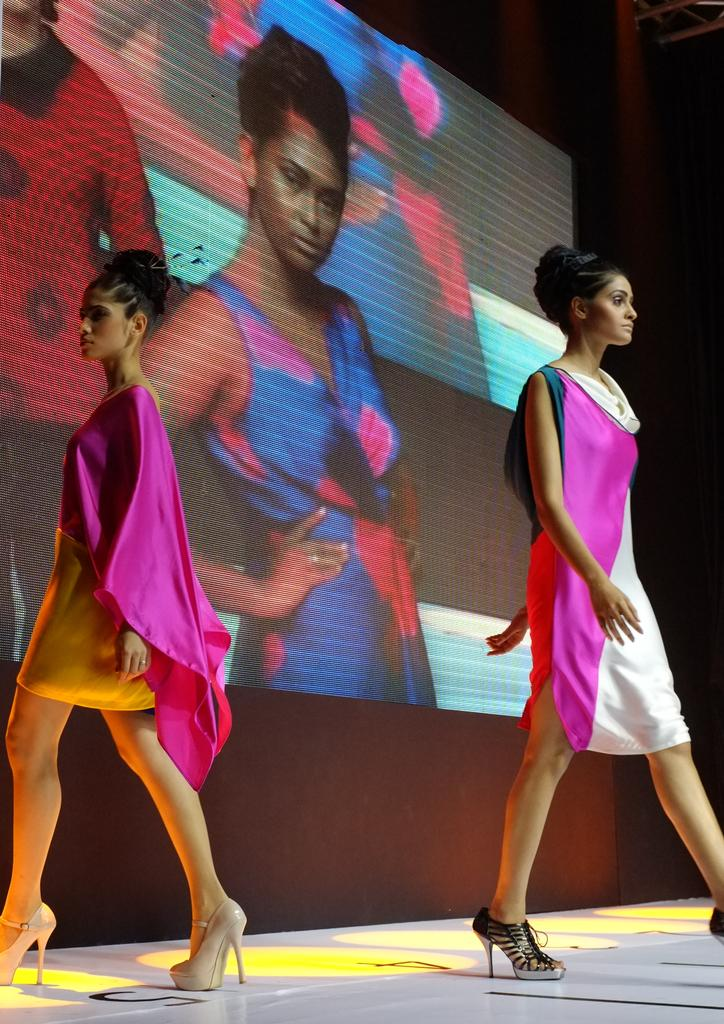How many people are in the image? There are two people in the image. What are the two people doing in the image? The two people are walking. Where are the two people walking? It appears that they are walking on a ramp. What can be seen in the background of the image? There is a screen visible in the background of the image. What type of rabbit can be seen hopping near the screen in the image? There is no rabbit present in the image; it only features two people walking on a ramp and a screen in the background. 